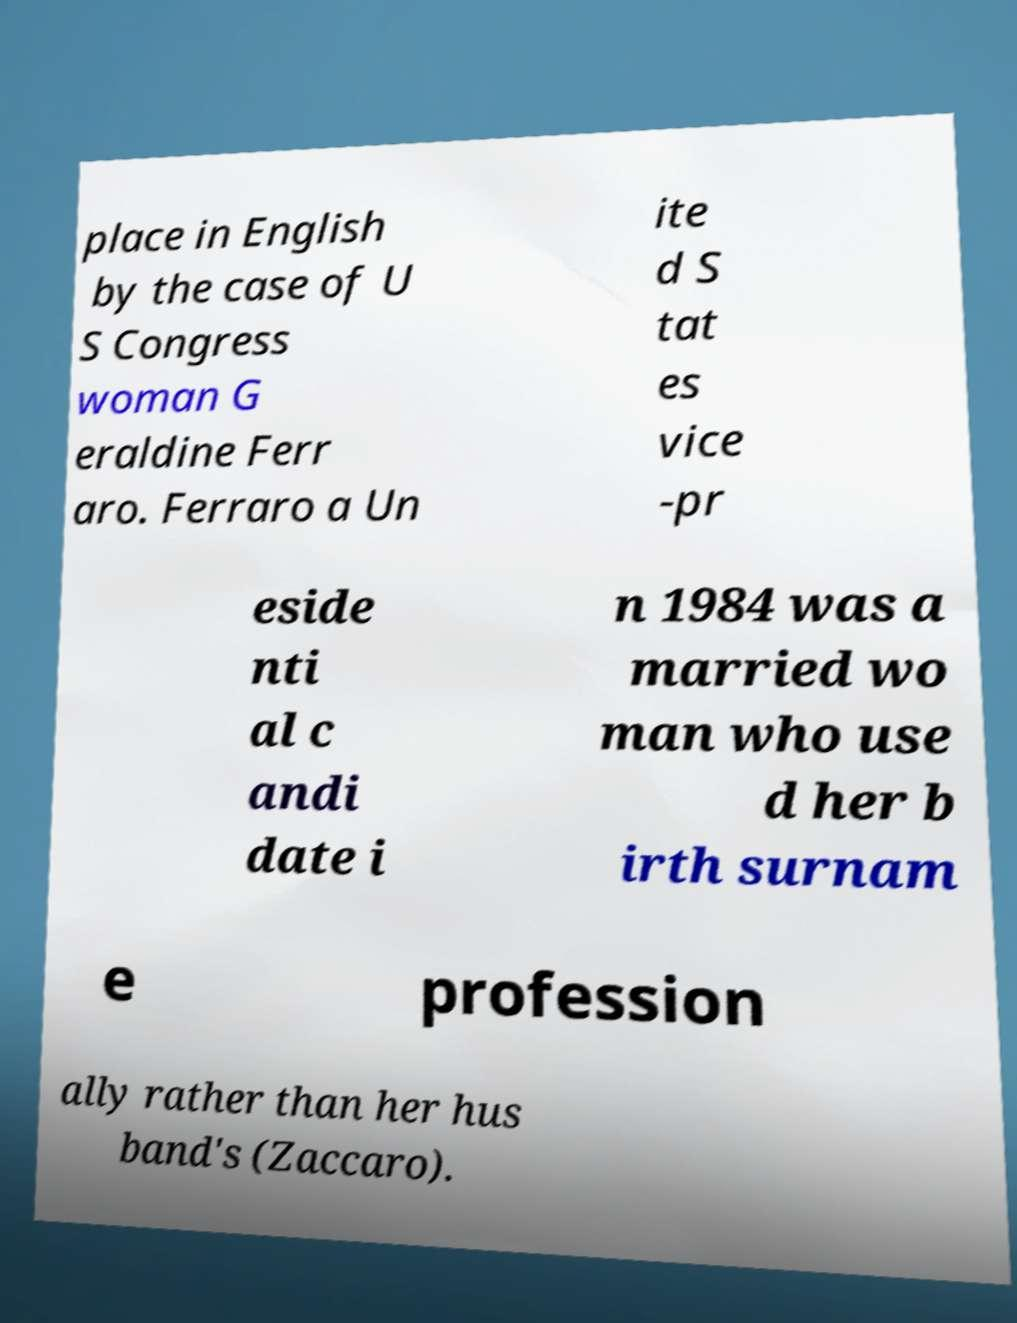Could you extract and type out the text from this image? place in English by the case of U S Congress woman G eraldine Ferr aro. Ferraro a Un ite d S tat es vice -pr eside nti al c andi date i n 1984 was a married wo man who use d her b irth surnam e profession ally rather than her hus band's (Zaccaro). 